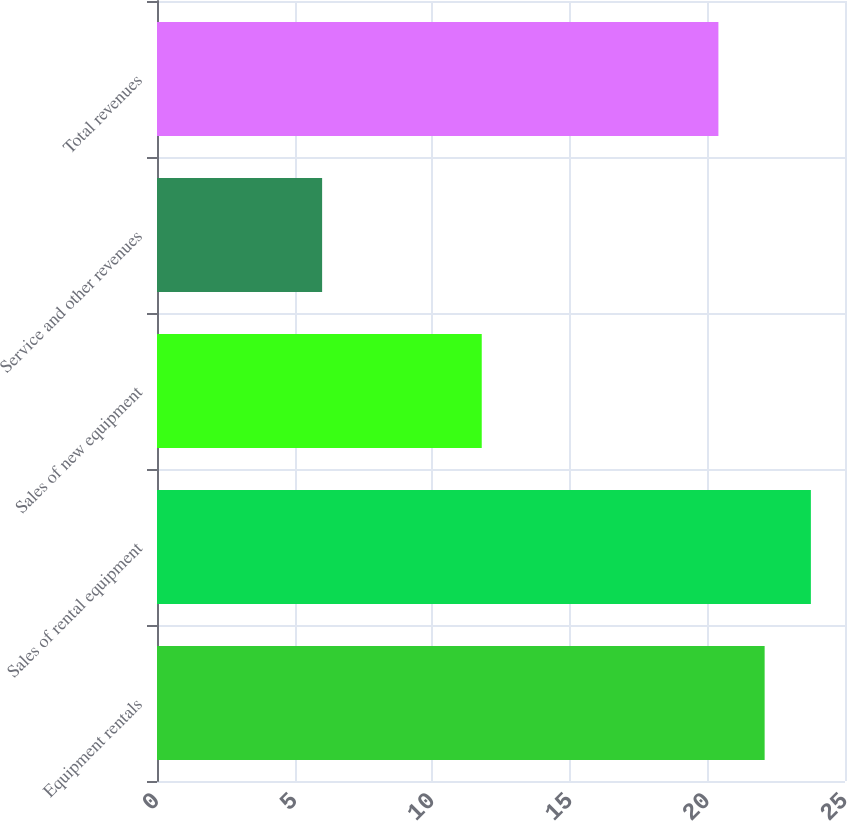Convert chart. <chart><loc_0><loc_0><loc_500><loc_500><bar_chart><fcel>Equipment rentals<fcel>Sales of rental equipment<fcel>Sales of new equipment<fcel>Service and other revenues<fcel>Total revenues<nl><fcel>22.08<fcel>23.76<fcel>11.8<fcel>6<fcel>20.4<nl></chart> 